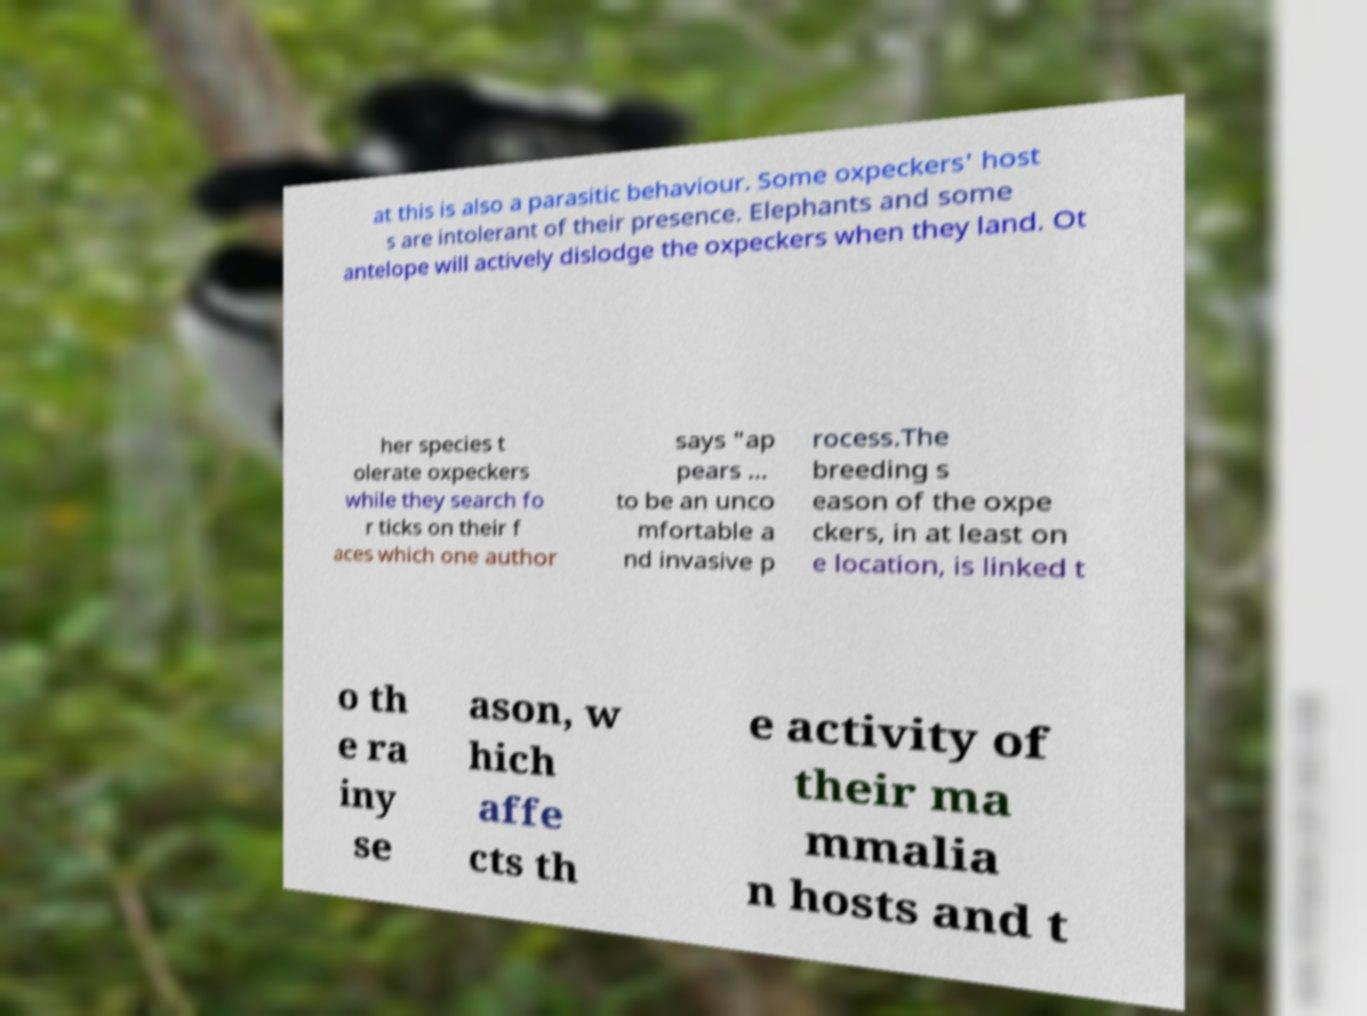For documentation purposes, I need the text within this image transcribed. Could you provide that? at this is also a parasitic behaviour. Some oxpeckers' host s are intolerant of their presence. Elephants and some antelope will actively dislodge the oxpeckers when they land. Ot her species t olerate oxpeckers while they search fo r ticks on their f aces which one author says "ap pears ... to be an unco mfortable a nd invasive p rocess.The breeding s eason of the oxpe ckers, in at least on e location, is linked t o th e ra iny se ason, w hich affe cts th e activity of their ma mmalia n hosts and t 